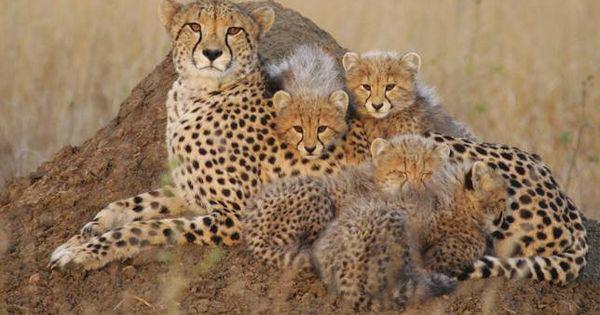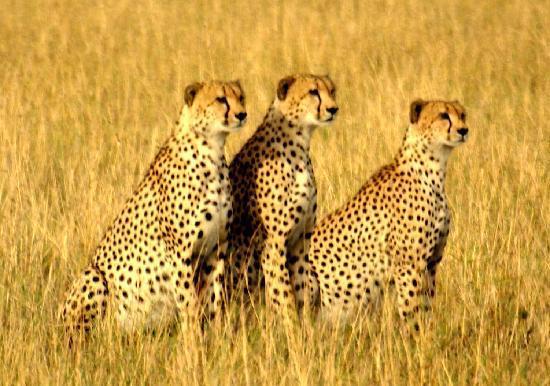The first image is the image on the left, the second image is the image on the right. For the images shown, is this caption "In one image, there are three cheetahs sitting on their haunches, and in the other image, there are at least three cheetahs lying down." true? Answer yes or no. Yes. The first image is the image on the left, the second image is the image on the right. For the images displayed, is the sentence "in the left image cheetahs are laying on a mound of dirt" factually correct? Answer yes or no. Yes. 